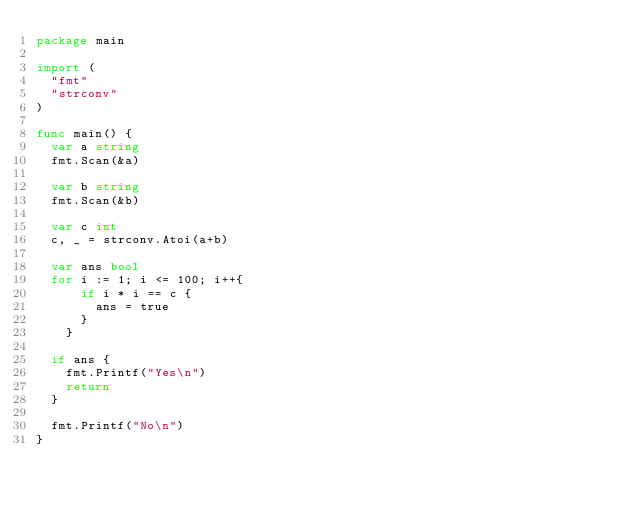<code> <loc_0><loc_0><loc_500><loc_500><_Go_>package main                 

import (
  "fmt"
  "strconv"
)

func main() {
  var a string
  fmt.Scan(&a)

  var b string
  fmt.Scan(&b)

  var c int
  c, _ = strconv.Atoi(a+b)

  var ans bool
  for i := 1; i <= 100; i++{
      if i * i == c {
        ans = true
      }
    }

  if ans {
    fmt.Printf("Yes\n")
    return
  }

  fmt.Printf("No\n")
}
</code> 